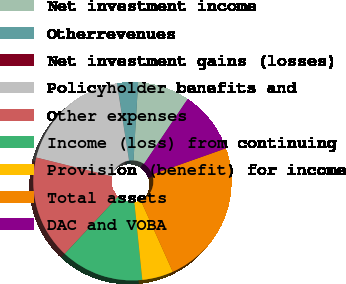Convert chart to OTSL. <chart><loc_0><loc_0><loc_500><loc_500><pie_chart><fcel>Net investment income<fcel>Otherrevenues<fcel>Net investment gains (losses)<fcel>Policyholder benefits and<fcel>Other expenses<fcel>Income (loss) from continuing<fcel>Provision (benefit) for income<fcel>Total assets<fcel>DAC and VOBA<nl><fcel>8.48%<fcel>3.4%<fcel>0.01%<fcel>18.64%<fcel>16.94%<fcel>13.56%<fcel>5.09%<fcel>23.71%<fcel>10.17%<nl></chart> 